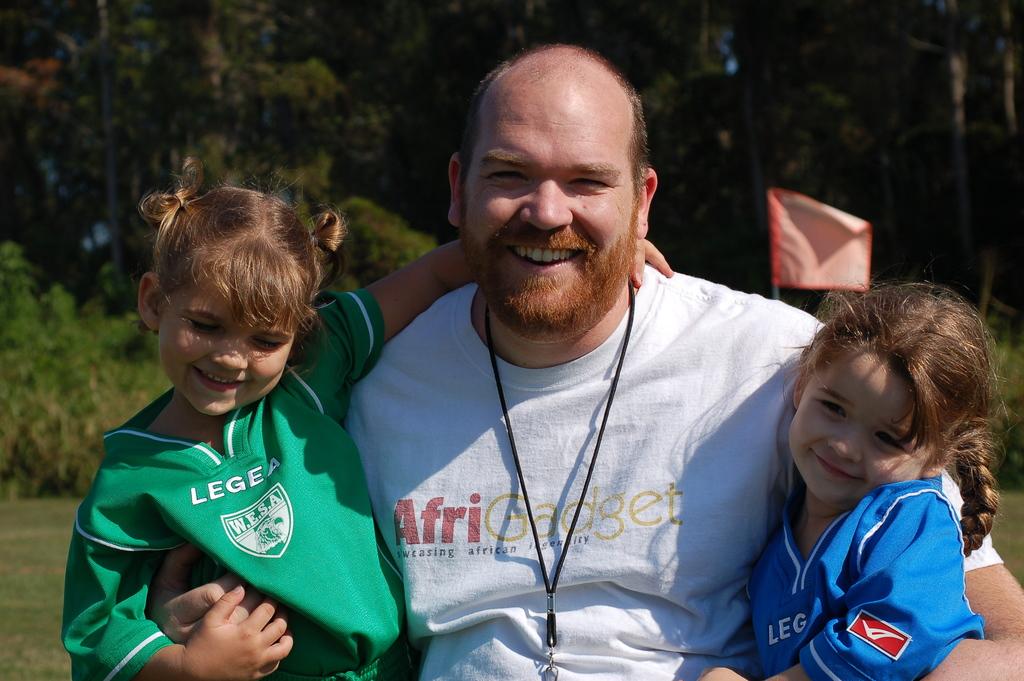What does the little girl on the left's shirt say?
Make the answer very short. Legea. 